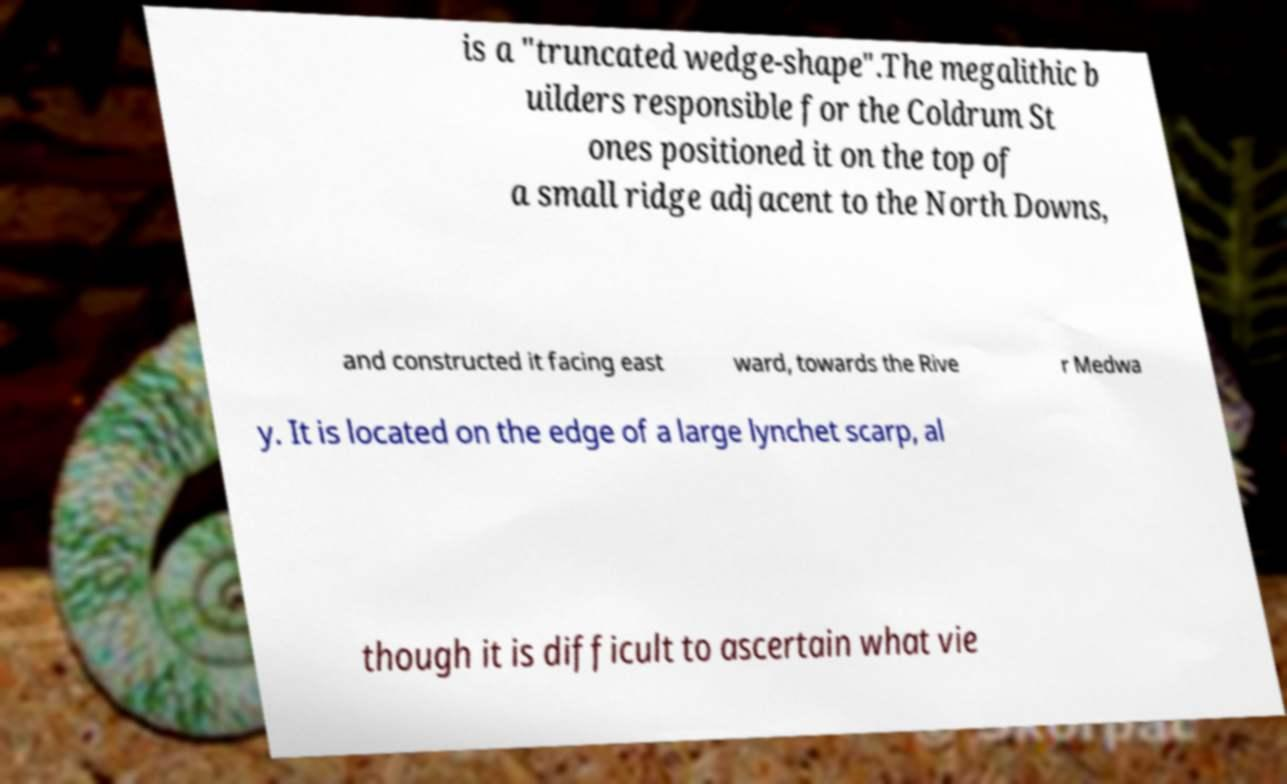What messages or text are displayed in this image? I need them in a readable, typed format. is a "truncated wedge-shape".The megalithic b uilders responsible for the Coldrum St ones positioned it on the top of a small ridge adjacent to the North Downs, and constructed it facing east ward, towards the Rive r Medwa y. It is located on the edge of a large lynchet scarp, al though it is difficult to ascertain what vie 